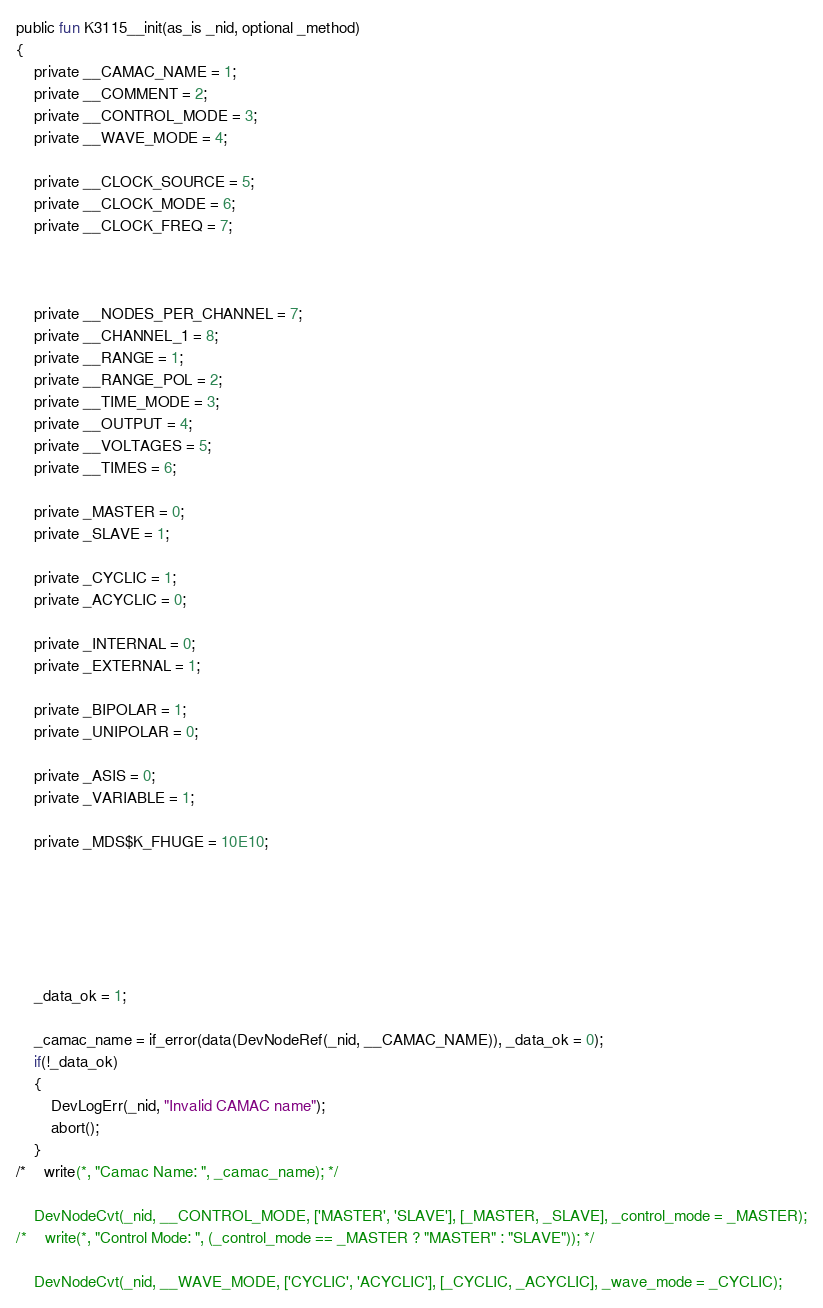Convert code to text. <code><loc_0><loc_0><loc_500><loc_500><_SML_>public fun K3115__init(as_is _nid, optional _method)
{
	private __CAMAC_NAME = 1;
	private __COMMENT = 2;
	private __CONTROL_MODE = 3;
	private __WAVE_MODE = 4;

	private __CLOCK_SOURCE = 5;
	private __CLOCK_MODE = 6;
	private __CLOCK_FREQ = 7;



	private __NODES_PER_CHANNEL = 7;
	private __CHANNEL_1 = 8;
	private __RANGE = 1;
	private __RANGE_POL = 2;
	private __TIME_MODE = 3;
	private __OUTPUT = 4;
	private __VOLTAGES = 5;
	private __TIMES = 6;

	private _MASTER = 0;
	private _SLAVE = 1;

	private _CYCLIC = 1;
	private _ACYCLIC = 0;

	private _INTERNAL = 0;
	private _EXTERNAL = 1;

	private _BIPOLAR = 1;
	private _UNIPOLAR = 0;

	private _ASIS = 0;
	private _VARIABLE = 1;

	private _MDS$K_FHUGE = 10E10;






	_data_ok = 1;

	_camac_name = if_error(data(DevNodeRef(_nid, __CAMAC_NAME)), _data_ok = 0);
	if(!_data_ok)
	{
		DevLogErr(_nid, "Invalid CAMAC name");
		abort();
	}
/*	write(*, "Camac Name: ", _camac_name); */

	DevNodeCvt(_nid, __CONTROL_MODE, ['MASTER', 'SLAVE'], [_MASTER, _SLAVE], _control_mode = _MASTER);
/*	write(*, "Control Mode: ", (_control_mode == _MASTER ? "MASTER" : "SLAVE")); */

	DevNodeCvt(_nid, __WAVE_MODE, ['CYCLIC', 'ACYCLIC'], [_CYCLIC, _ACYCLIC], _wave_mode = _CYCLIC);</code> 